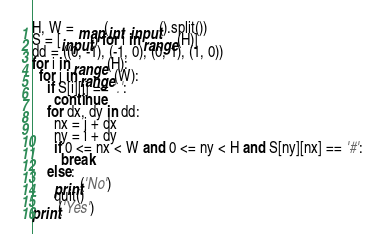Convert code to text. <code><loc_0><loc_0><loc_500><loc_500><_Python_>H, W = map(int, input().split())
S = [input() for i in range(H)]
dd = ((0, -1), (-1, 0), (0, 1), (1, 0))
for i in range(H):
  for j in range(W):
    if S[i][j] == '.':
      continue
    for dx, dy in dd:
      nx = j + dx
      ny = i + dy
      if 0 <= nx < W and 0 <= ny < H and S[ny][nx] == '#':
        break
    else:
      print('No')
      quit()
print('Yes')
</code> 